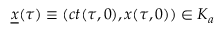Convert formula to latex. <formula><loc_0><loc_0><loc_500><loc_500>\underline { x } ( \tau ) \equiv \left ( c t ( \tau , 0 ) , x ( \tau , 0 ) \right ) \in K _ { a }</formula> 